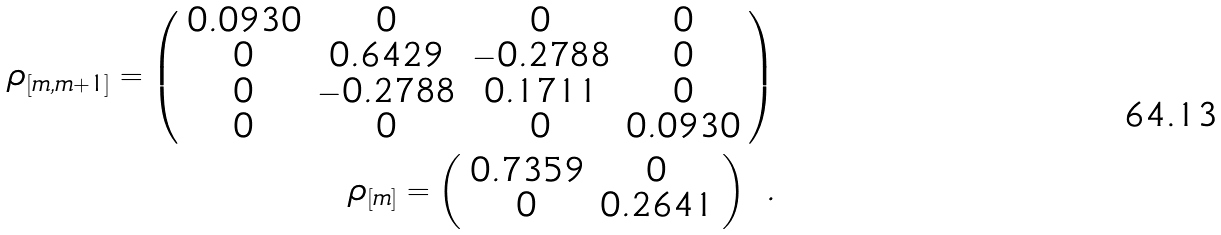Convert formula to latex. <formula><loc_0><loc_0><loc_500><loc_500>\rho _ { \left [ m , m + 1 \right ] } = \left ( \begin{array} { c c c c } 0 . 0 9 3 0 & 0 & 0 & 0 \\ 0 & 0 . 6 4 2 9 & - 0 . 2 7 8 8 & 0 \\ 0 & - 0 . 2 7 8 8 & 0 . 1 7 1 1 & 0 \\ 0 & 0 & 0 & 0 . 0 9 3 0 \\ \end{array} \right ) \\ \rho _ { \left [ m \right ] } = \left ( \begin{array} { c c } 0 . 7 3 5 9 & 0 \\ 0 & 0 . 2 6 4 1 \\ \end{array} \right ) \ .</formula> 